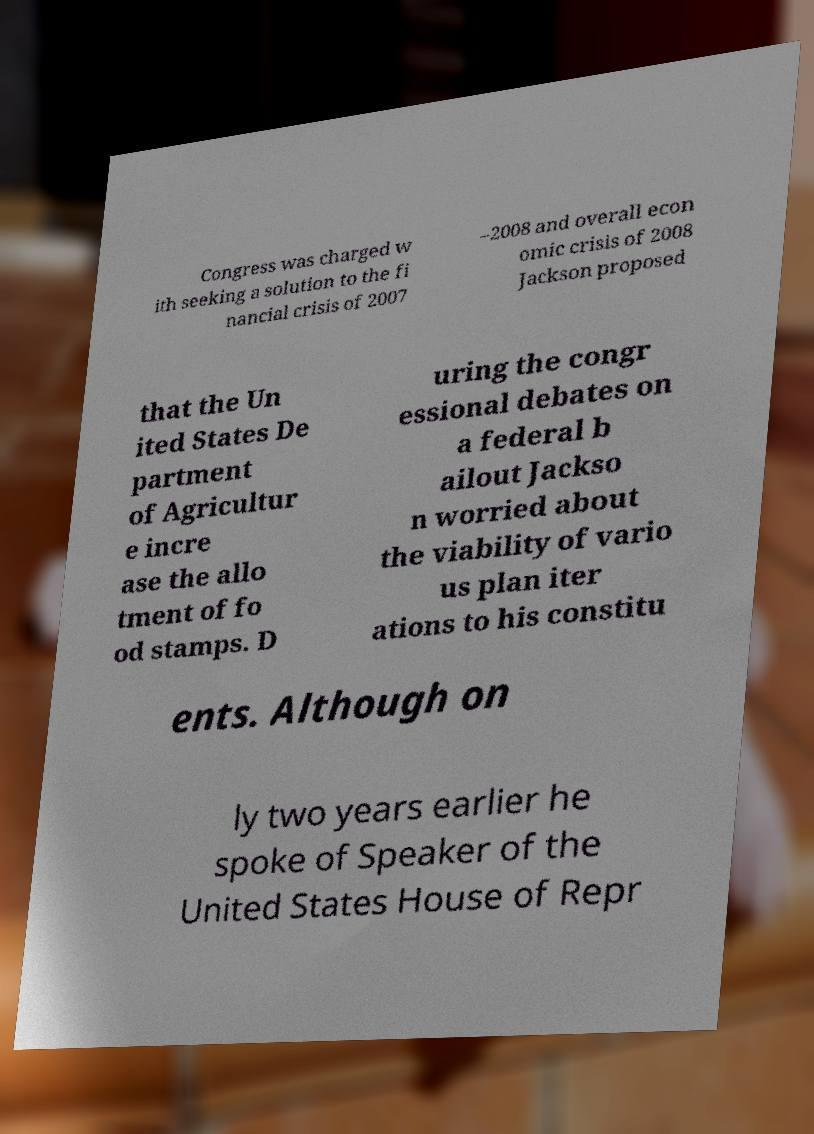There's text embedded in this image that I need extracted. Can you transcribe it verbatim? Congress was charged w ith seeking a solution to the fi nancial crisis of 2007 –2008 and overall econ omic crisis of 2008 Jackson proposed that the Un ited States De partment of Agricultur e incre ase the allo tment of fo od stamps. D uring the congr essional debates on a federal b ailout Jackso n worried about the viability of vario us plan iter ations to his constitu ents. Although on ly two years earlier he spoke of Speaker of the United States House of Repr 